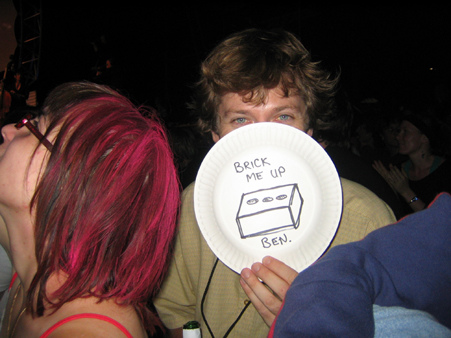<image>
Can you confirm if the plate is under the person? No. The plate is not positioned under the person. The vertical relationship between these objects is different. 